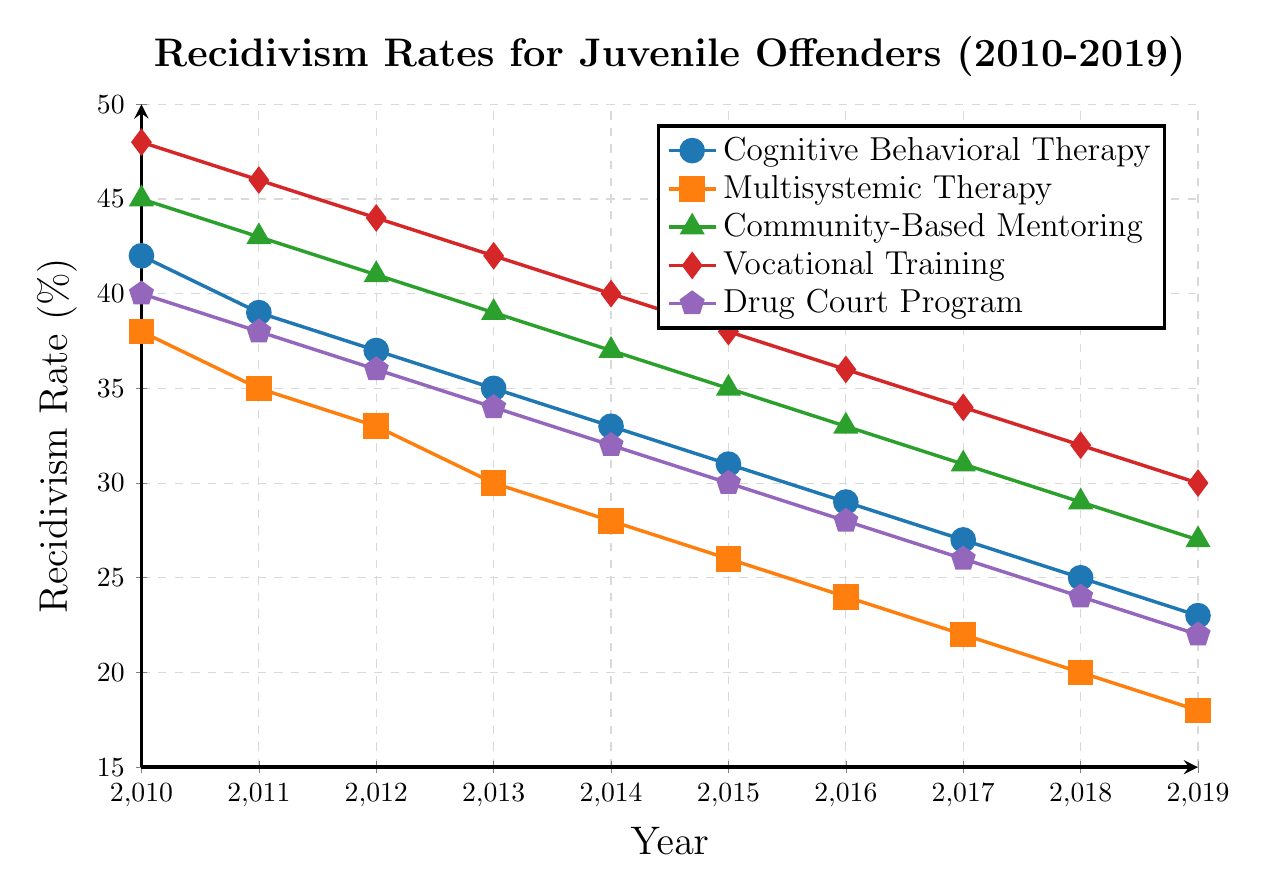What's the overall trend in recidivism rates for the Drug Court Program from 2010 to 2019? The recidivism rates for the Drug Court Program show a consistent downward trend from 2010 (40%) to 2019 (22%). This indicates an improvement in reducing recidivism over the years.
Answer: Downward trend Which rehabilitation program had the lowest recidivism rate in 2019? By referring to the data points in the figure for the year 2019, we can see the recidivism rates as follows: Cognitive Behavioral Therapy (23%), Multisystemic Therapy (18%), Community-Based Mentoring (27%), Vocational Training (30%), Drug Court Program (22%). The lowest rate is 18% for Multisystemic Therapy.
Answer: Multisystemic Therapy Between Cognitive Behavioral Therapy and Vocational Training, which one showed a greater reduction in recidivism rates from 2010 to 2019? For Cognitive Behavioral Therapy: 2010 (42%) to 2019 (23%), a reduction of 42 - 23 = 19%. For Vocational Training: 2010 (48%) to 2019 (30%), a reduction of 48 - 30 = 18%. Therefore, Cognitive Behavioral Therapy showed a greater reduction.
Answer: Cognitive Behavioral Therapy In which year did Community-Based Mentoring and Vocational Training have the same recidivism rate? By comparing the recidivism rates year by year for both programs, we see that in 2016, both Community-Based Mentoring and Vocational Training had a recidivism rate of 36%.
Answer: 2016 What is the average recidivism rate for Multisystemic Therapy across the years 2010 to 2019? The recidivism rates for Multisystemic Therapy are: 38%, 35%, 33%, 30%, 28%, 26%, 24%, 22%, 20%, 18%. Summing these up gives (38+35+33+30+28+26+24+22+20+18) = 274. Dividing by 10 (number of years) yields an average rate of 274/10 = 27.4%.
Answer: 27.4% Which rehabilitation program had the steepest decline in recidivism rates over the decade? To find the steepest decline, calculate the difference between the 2010 and 2019 rates for each program:
- Cognitive Behavioral Therapy: 42% - 23% = 19%
- Multisystemic Therapy: 38% - 18% = 20%
- Community-Based Mentoring: 45% - 27% = 18%
- Vocational Training: 48% - 30% = 18%
- Drug Court Program: 40% - 22% = 18%
The steepest decline is 20% for Multisystemic Therapy.
Answer: Multisystemic Therapy If you add the recidivism rates of Cognitive Behavioral Therapy and Community-Based Mentoring for the year 2014, what is the total? In 2014, the recidivism rates are Cognitive Behavioral Therapy (33%) and Community-Based Mentoring (37%). Adding these together gives 33 + 37 = 70.
Answer: 70 Which program consistently had the highest recidivism rate from 2010 to 2019? By examining the data points year by year, Vocational Training consistently has the highest recidivism rate each year from 2010 (48%) to 2019 (30%).
Answer: Vocational Training What was the recidivism rate for Drug Court Program in 2015 and how did it compare to that of Multisystemic Therapy in the same year? In 2015, the recidivism rate for Drug Court Program was 30%, and for Multisystemic Therapy, it was 26%. Comparing them, Drug Court Program had a 4% higher recidivism rate than Multisystemic Therapy.
Answer: Drug Court Program was 4% higher 